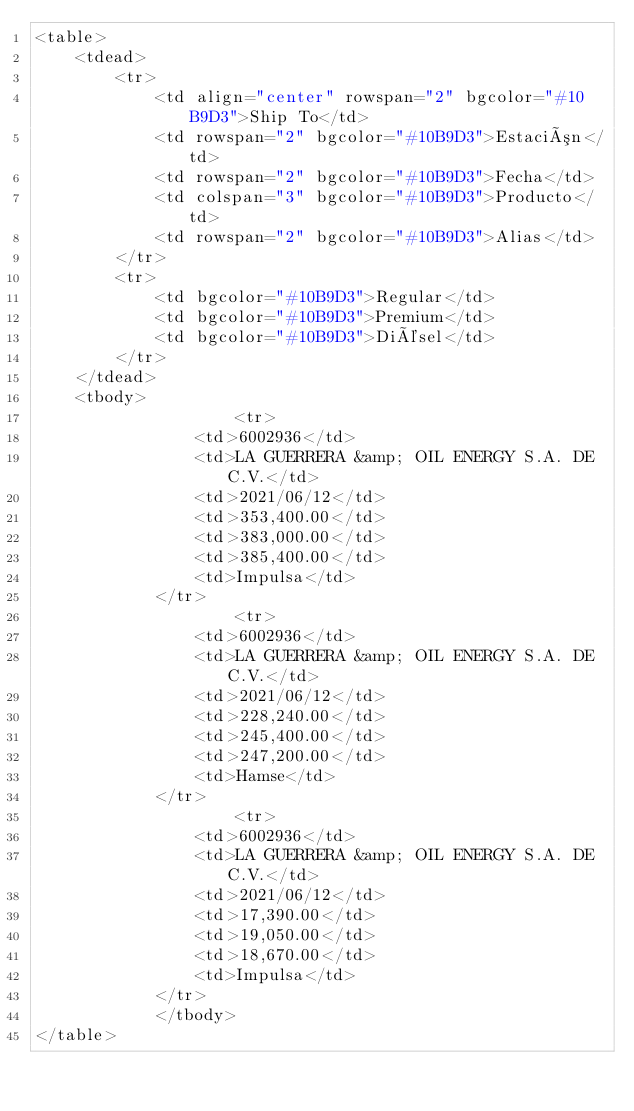<code> <loc_0><loc_0><loc_500><loc_500><_HTML_><table>
    <tdead>
        <tr>
            <td align="center" rowspan="2" bgcolor="#10B9D3">Ship To</td>
            <td rowspan="2" bgcolor="#10B9D3">Estación</td>
            <td rowspan="2" bgcolor="#10B9D3">Fecha</td>
            <td colspan="3" bgcolor="#10B9D3">Producto</td>
            <td rowspan="2" bgcolor="#10B9D3">Alias</td>
        </tr>
        <tr>
            <td bgcolor="#10B9D3">Regular</td>
            <td bgcolor="#10B9D3">Premium</td>
            <td bgcolor="#10B9D3">Diésel</td>
        </tr>
    </tdead>
    <tbody>
                    <tr>
                <td>6002936</td>
                <td>LA GUERRERA &amp; OIL ENERGY S.A. DE C.V.</td>
                <td>2021/06/12</td>
                <td>353,400.00</td>
                <td>383,000.00</td>
                <td>385,400.00</td>
                <td>Impulsa</td>
            </tr>
                    <tr>
                <td>6002936</td>
                <td>LA GUERRERA &amp; OIL ENERGY S.A. DE C.V.</td>
                <td>2021/06/12</td>
                <td>228,240.00</td>
                <td>245,400.00</td>
                <td>247,200.00</td>
                <td>Hamse</td>
            </tr>
                    <tr>
                <td>6002936</td>
                <td>LA GUERRERA &amp; OIL ENERGY S.A. DE C.V.</td>
                <td>2021/06/12</td>
                <td>17,390.00</td>
                <td>19,050.00</td>
                <td>18,670.00</td>
                <td>Impulsa</td>
            </tr>
            </tbody>
</table>
</code> 